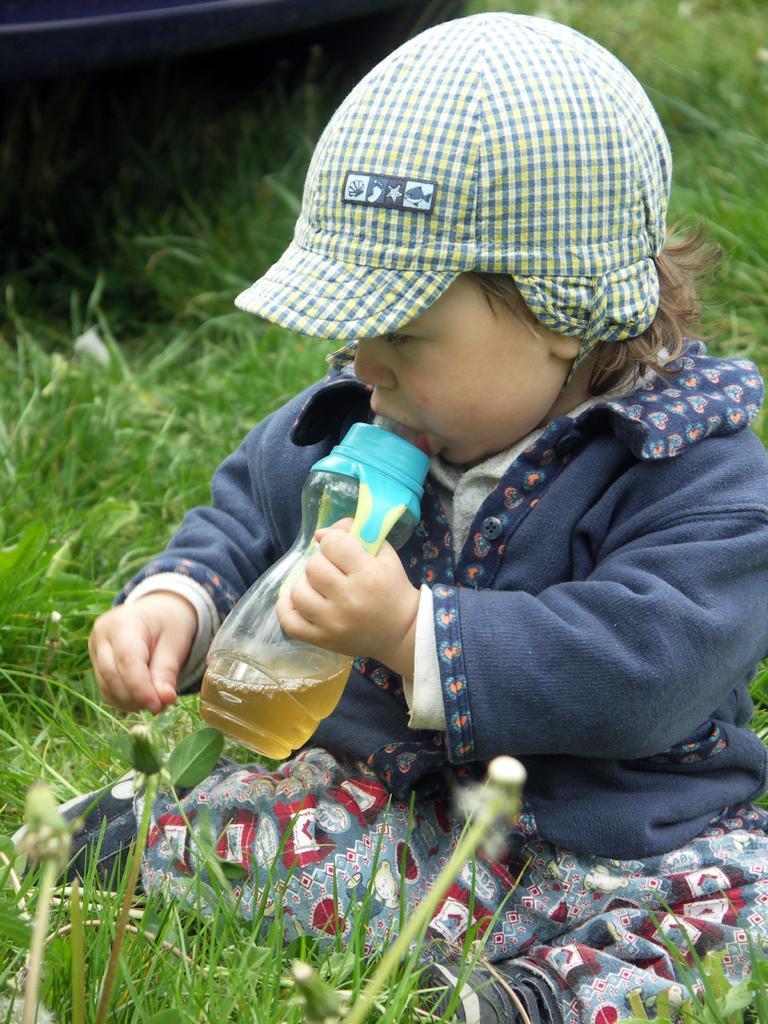Who is the main subject in the image? There is a girl in the image. What is the girl holding in the image? The girl is holding a bottle. What type of clothing is the girl wearing in the image? The girl is wearing a cap. What type of environment is visible in the image? There is grass visible in the image. What type of education is the girl pursuing in the image? There is no indication of the girl pursuing any education in the image. What role does the girl's grandfather play in the image? There is no mention of a grandfather in the image. 